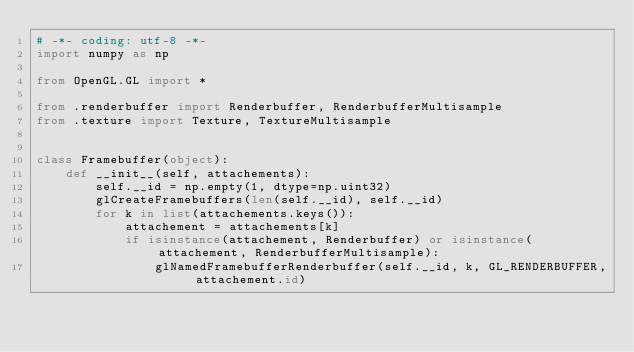<code> <loc_0><loc_0><loc_500><loc_500><_Python_># -*- coding: utf-8 -*-
import numpy as np

from OpenGL.GL import *

from .renderbuffer import Renderbuffer, RenderbufferMultisample
from .texture import Texture, TextureMultisample


class Framebuffer(object):
    def __init__(self, attachements):
        self.__id = np.empty(1, dtype=np.uint32)
        glCreateFramebuffers(len(self.__id), self.__id)
        for k in list(attachements.keys()):
            attachement = attachements[k]
            if isinstance(attachement, Renderbuffer) or isinstance(attachement, RenderbufferMultisample):
                glNamedFramebufferRenderbuffer(self.__id, k, GL_RENDERBUFFER, attachement.id)</code> 